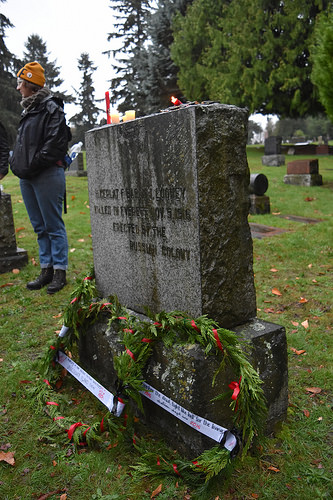<image>
Is there a man in front of the stone? No. The man is not in front of the stone. The spatial positioning shows a different relationship between these objects. 